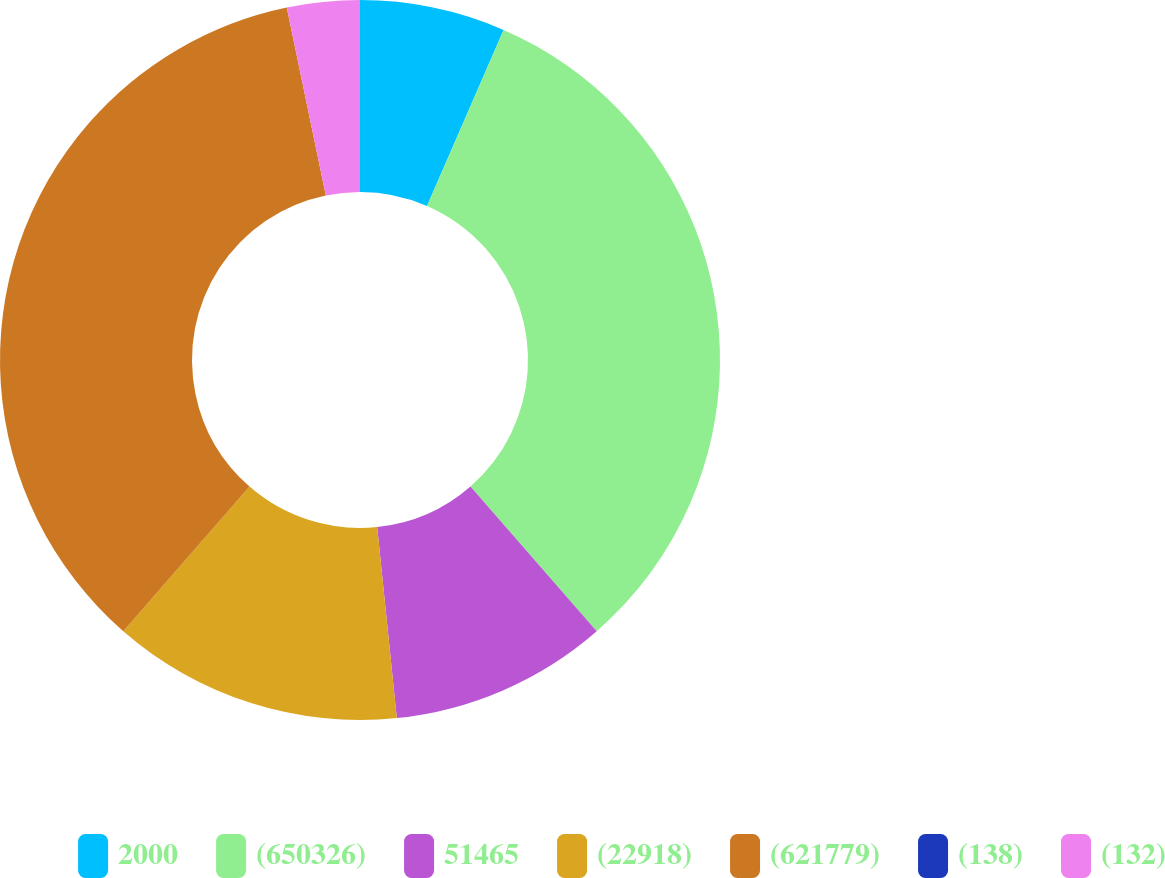Convert chart to OTSL. <chart><loc_0><loc_0><loc_500><loc_500><pie_chart><fcel>2000<fcel>(650326)<fcel>51465<fcel>(22918)<fcel>(621779)<fcel>(138)<fcel>(132)<nl><fcel>6.53%<fcel>32.05%<fcel>9.79%<fcel>13.05%<fcel>35.32%<fcel>0.0%<fcel>3.26%<nl></chart> 